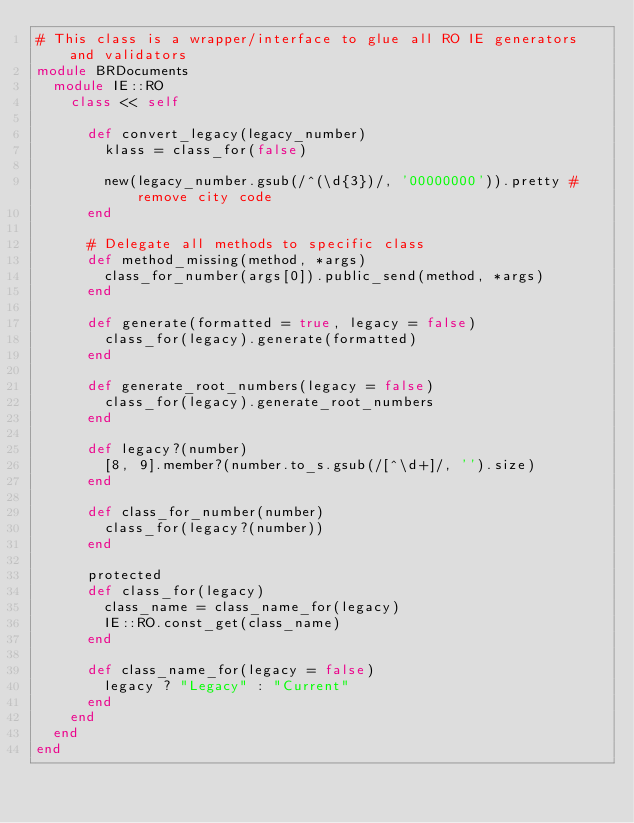Convert code to text. <code><loc_0><loc_0><loc_500><loc_500><_Ruby_># This class is a wrapper/interface to glue all RO IE generators and validators
module BRDocuments
  module IE::RO
    class << self

      def convert_legacy(legacy_number)
        klass = class_for(false)

        new(legacy_number.gsub(/^(\d{3})/, '00000000')).pretty # remove city code
      end

      # Delegate all methods to specific class
      def method_missing(method, *args)
        class_for_number(args[0]).public_send(method, *args)
      end

      def generate(formatted = true, legacy = false)
        class_for(legacy).generate(formatted)
      end

      def generate_root_numbers(legacy = false)
        class_for(legacy).generate_root_numbers
      end

      def legacy?(number)
        [8, 9].member?(number.to_s.gsub(/[^\d+]/, '').size)
      end

      def class_for_number(number)
        class_for(legacy?(number))
      end

      protected
      def class_for(legacy)
        class_name = class_name_for(legacy)
        IE::RO.const_get(class_name)
      end

      def class_name_for(legacy = false)
        legacy ? "Legacy" : "Current"
      end
    end
  end
end</code> 